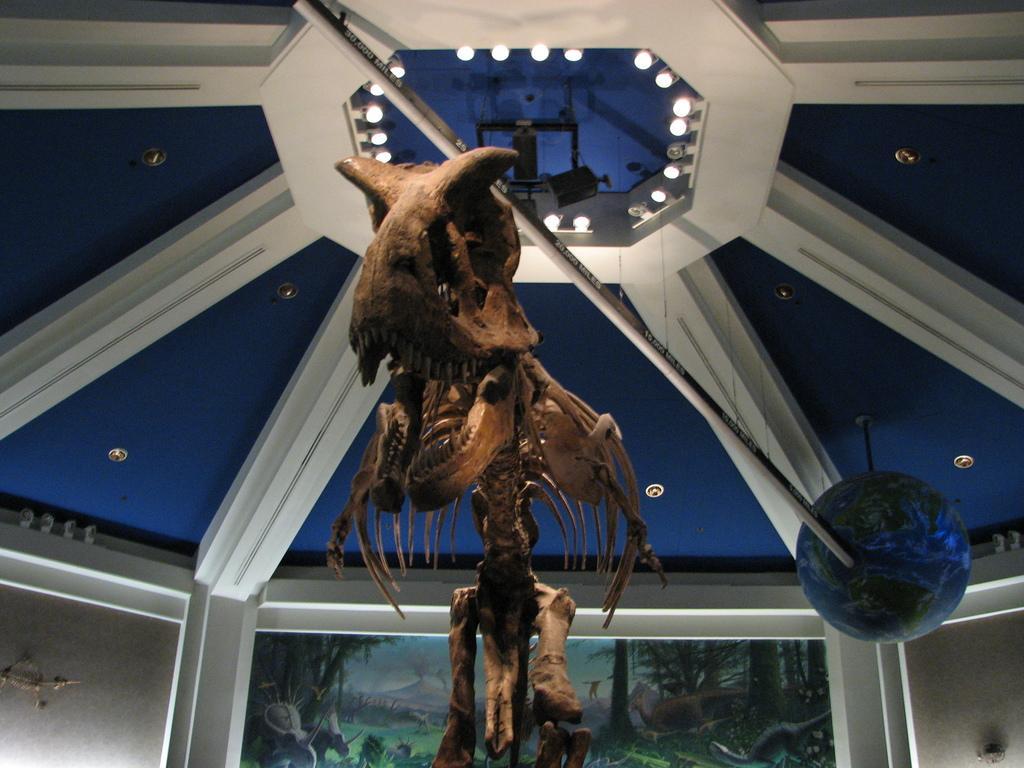Describe this image in one or two sentences. Here we can see a skeleton. Painting is on the wall. These are lights.  